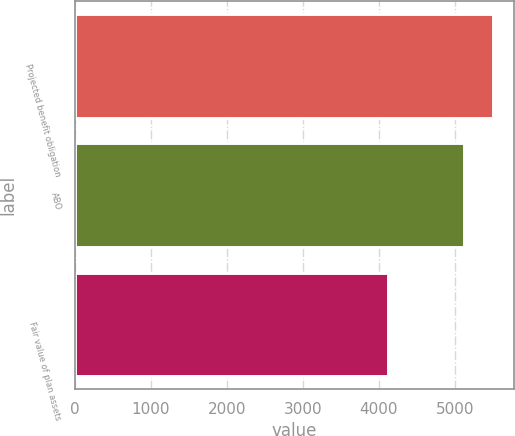<chart> <loc_0><loc_0><loc_500><loc_500><bar_chart><fcel>Projected benefit obligation<fcel>ABO<fcel>Fair value of plan assets<nl><fcel>5509.2<fcel>5119.6<fcel>4126.2<nl></chart> 